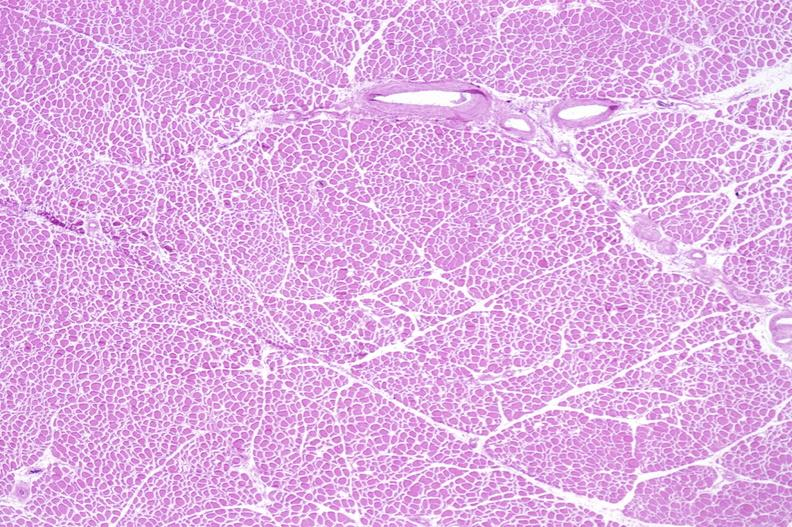s soft tissue present?
Answer the question using a single word or phrase. Yes 